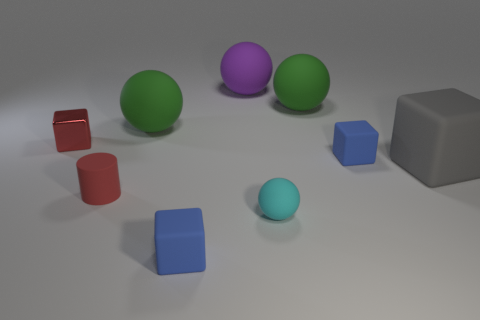The tiny red matte thing has what shape?
Your answer should be compact. Cylinder. What number of spheres are either purple objects or small blue rubber objects?
Keep it short and to the point. 1. Is the number of small matte objects behind the big gray thing the same as the number of cyan rubber things to the left of the tiny red rubber object?
Your answer should be very brief. No. There is a small blue rubber block behind the gray matte object that is behind the tiny cyan object; what number of red cylinders are on the left side of it?
Your response must be concise. 1. There is a tiny matte object that is the same color as the shiny object; what is its shape?
Give a very brief answer. Cylinder. There is a metallic thing; does it have the same color as the big rubber object in front of the red metallic cube?
Provide a succinct answer. No. Are there more cyan matte spheres right of the big gray rubber block than gray cubes?
Offer a very short reply. No. What number of things are either small matte things on the right side of the tiny cylinder or tiny blue objects in front of the gray rubber thing?
Offer a very short reply. 3. There is a purple thing that is the same material as the small red cylinder; what size is it?
Provide a short and direct response. Large. Does the small red thing in front of the gray rubber block have the same shape as the large gray rubber thing?
Make the answer very short. No. 